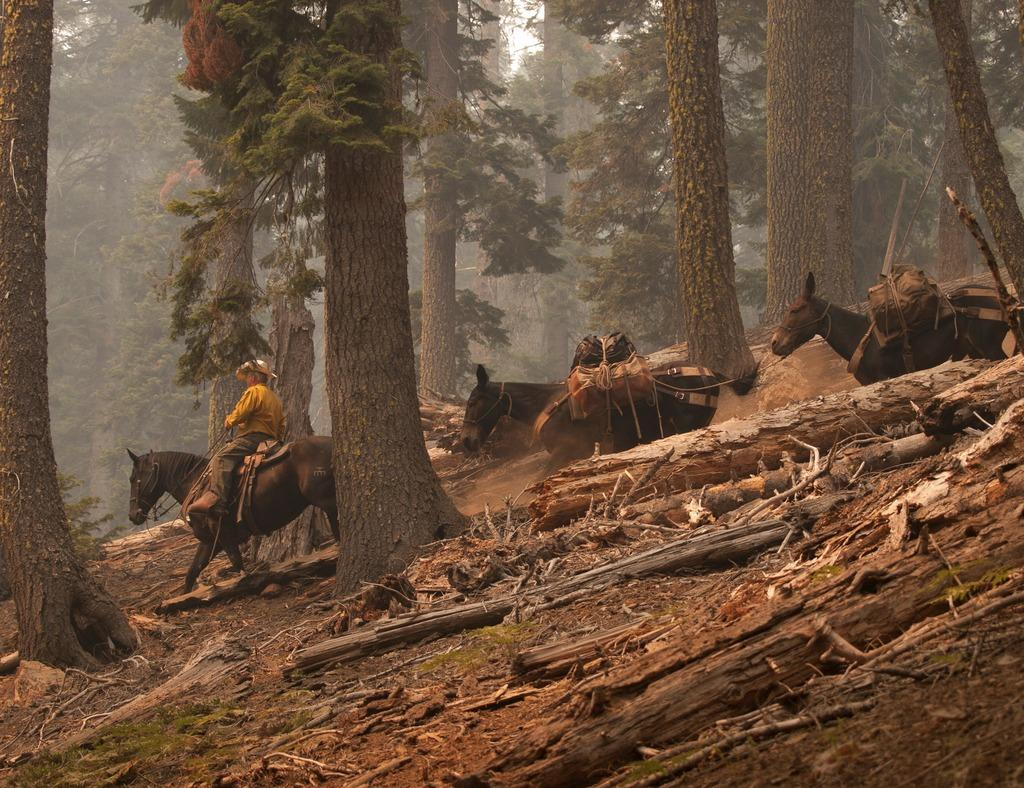What type of material is used to make the barks in the image? The wooden barks in the image are made of wood. What animals are present in the image? There are horses in the image. Is there a person interacting with the horses in the image? Yes, a man is seated on one of the horses. What can be seen in the background of the image? There are trees visible in the background of the image. What type of hose is being used to water the trees in the image? There is no hose present in the image; it features wooden barks, horses, and a man on a horse. Can you confirm the existence of metal objects in the image? There is no mention of metal objects in the provided facts, so we cannot confirm their existence in the image. 